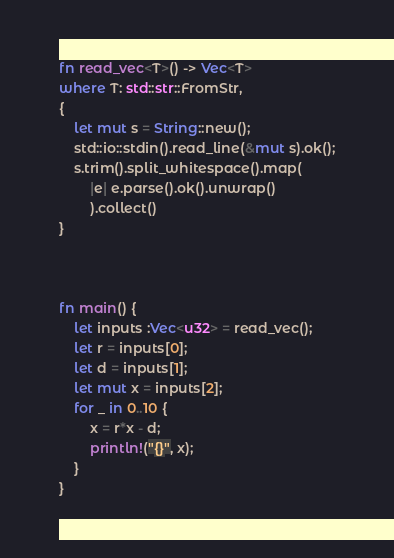Convert code to text. <code><loc_0><loc_0><loc_500><loc_500><_Rust_>fn read_vec<T>() -> Vec<T>
where T: std::str::FromStr,
{
    let mut s = String::new();
    std::io::stdin().read_line(&mut s).ok();
    s.trim().split_whitespace().map(
        |e| e.parse().ok().unwrap()
        ).collect()
}



fn main() {
    let inputs :Vec<u32> = read_vec();
    let r = inputs[0];
    let d = inputs[1];
    let mut x = inputs[2];
    for _ in 0..10 {
        x = r*x - d;
        println!("{}", x);
    }
}
</code> 